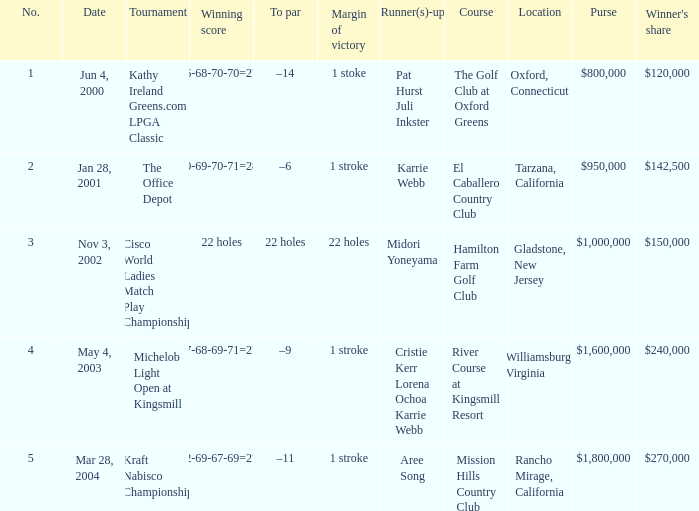Where is the margin of victory dated mar 28, 2004? 1 stroke. 